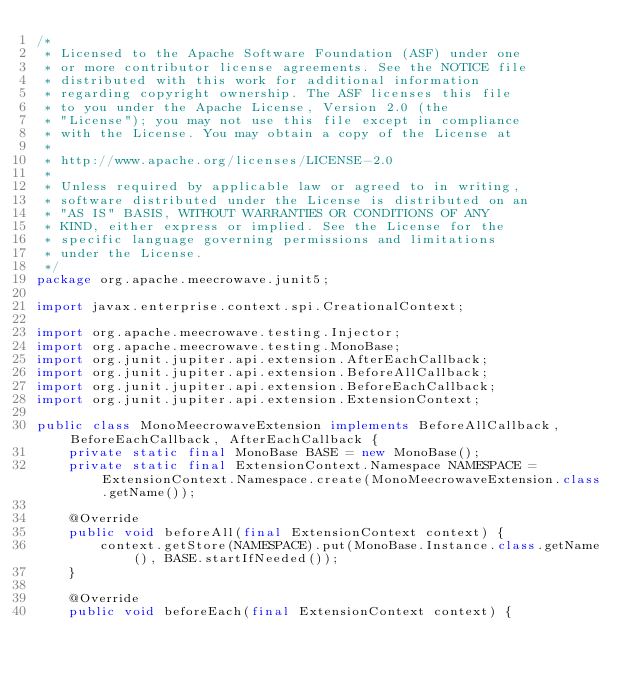<code> <loc_0><loc_0><loc_500><loc_500><_Java_>/*
 * Licensed to the Apache Software Foundation (ASF) under one
 * or more contributor license agreements. See the NOTICE file
 * distributed with this work for additional information
 * regarding copyright ownership. The ASF licenses this file
 * to you under the Apache License, Version 2.0 (the
 * "License"); you may not use this file except in compliance
 * with the License. You may obtain a copy of the License at
 *
 * http://www.apache.org/licenses/LICENSE-2.0
 *
 * Unless required by applicable law or agreed to in writing,
 * software distributed under the License is distributed on an
 * "AS IS" BASIS, WITHOUT WARRANTIES OR CONDITIONS OF ANY
 * KIND, either express or implied. See the License for the
 * specific language governing permissions and limitations
 * under the License.
 */
package org.apache.meecrowave.junit5;

import javax.enterprise.context.spi.CreationalContext;

import org.apache.meecrowave.testing.Injector;
import org.apache.meecrowave.testing.MonoBase;
import org.junit.jupiter.api.extension.AfterEachCallback;
import org.junit.jupiter.api.extension.BeforeAllCallback;
import org.junit.jupiter.api.extension.BeforeEachCallback;
import org.junit.jupiter.api.extension.ExtensionContext;

public class MonoMeecrowaveExtension implements BeforeAllCallback, BeforeEachCallback, AfterEachCallback {
    private static final MonoBase BASE = new MonoBase();
    private static final ExtensionContext.Namespace NAMESPACE = ExtensionContext.Namespace.create(MonoMeecrowaveExtension.class.getName());

    @Override
    public void beforeAll(final ExtensionContext context) {
        context.getStore(NAMESPACE).put(MonoBase.Instance.class.getName(), BASE.startIfNeeded());
    }

    @Override
    public void beforeEach(final ExtensionContext context) {</code> 